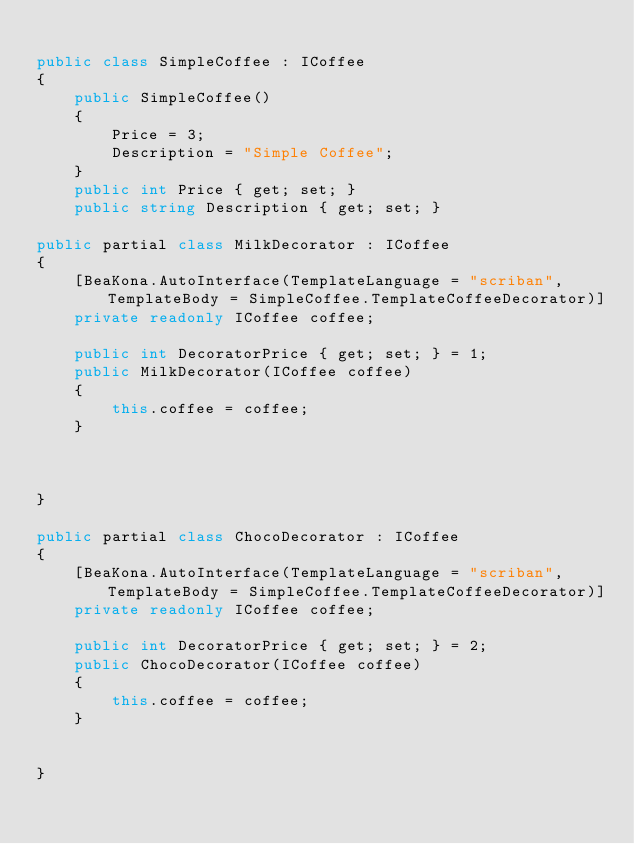<code> <loc_0><loc_0><loc_500><loc_500><_C#_>
public class SimpleCoffee : ICoffee
{
    public SimpleCoffee()
    {
        Price = 3;
        Description = "Simple Coffee";
    }
    public int Price { get; set; }
    public string Description { get; set; }

public partial class MilkDecorator : ICoffee
{
    [BeaKona.AutoInterface(TemplateLanguage = "scriban", TemplateBody = SimpleCoffee.TemplateCoffeeDecorator)]
    private readonly ICoffee coffee;

    public int DecoratorPrice { get; set; } = 1;
    public MilkDecorator(ICoffee coffee)
    {
        this.coffee = coffee;
    }



}

public partial class ChocoDecorator : ICoffee
{
    [BeaKona.AutoInterface(TemplateLanguage = "scriban", TemplateBody = SimpleCoffee.TemplateCoffeeDecorator)]
    private readonly ICoffee coffee;

    public int DecoratorPrice { get; set; } = 2;
    public ChocoDecorator(ICoffee coffee)
    {
        this.coffee = coffee;
    }


}
</code> 